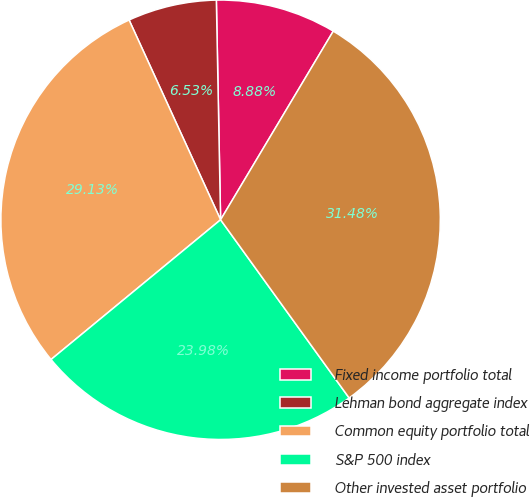<chart> <loc_0><loc_0><loc_500><loc_500><pie_chart><fcel>Fixed income portfolio total<fcel>Lehman bond aggregate index<fcel>Common equity portfolio total<fcel>S&P 500 index<fcel>Other invested asset portfolio<nl><fcel>8.88%<fcel>6.53%<fcel>29.14%<fcel>23.98%<fcel>31.49%<nl></chart> 